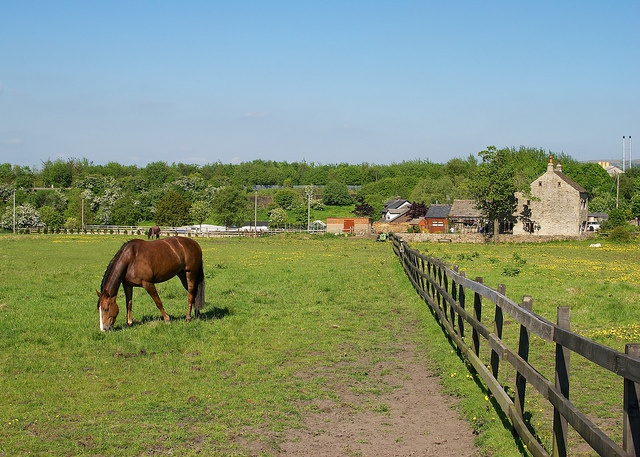Describe the objects in this image and their specific colors. I can see horse in lightblue, maroon, black, and brown tones and horse in lightblue, black, brown, maroon, and gray tones in this image. 